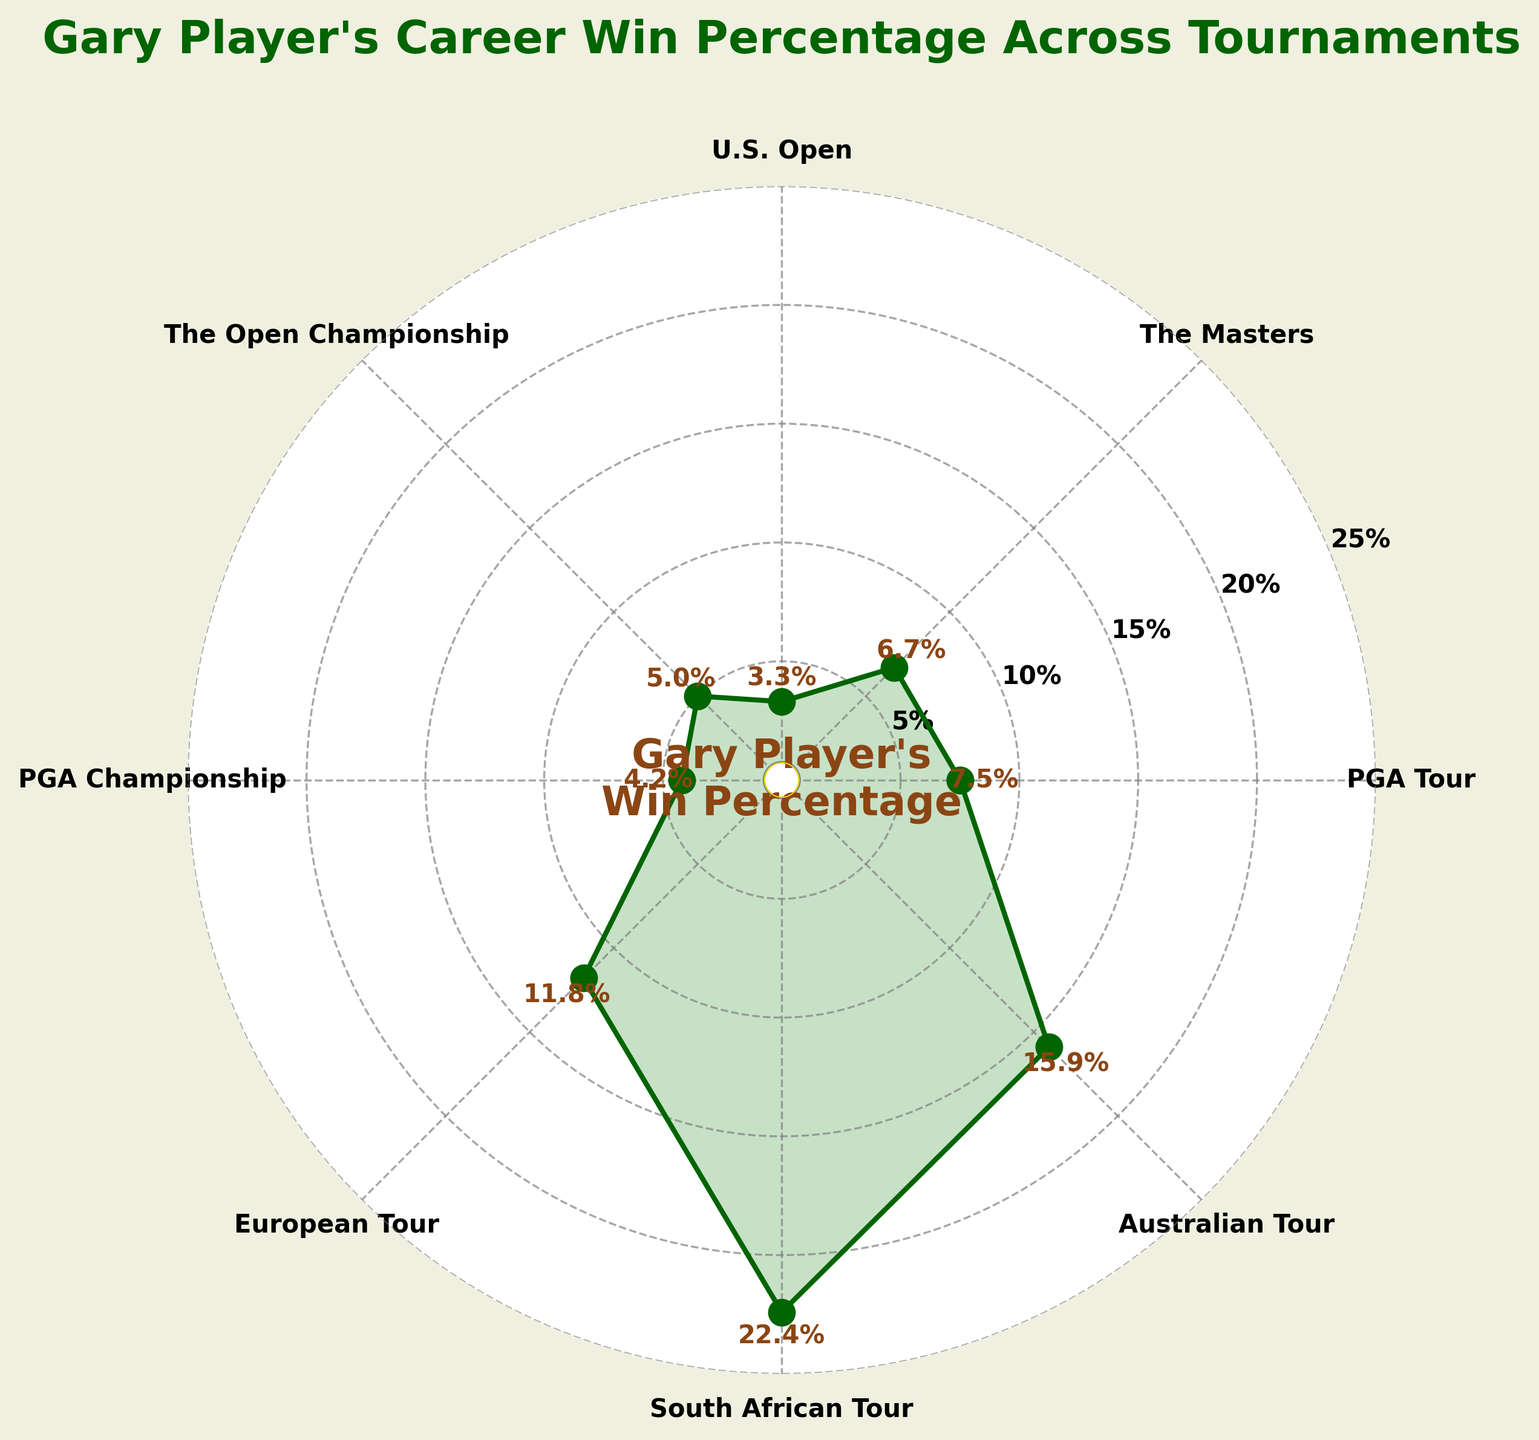what is the win percentage for Gary Player in "The Masters"? The win percentage for "The Masters" is indicated on the plot. It is labeled on the axis and marked with text near the data point. The value is 6.7%.
Answer: 6.7% Which tournament has the highest win percentage? Observing the plot, the highest point on the radial axis corresponds to the South African Tour, which has the win percentage of 22.4%.
Answer: South African Tour How many tournaments have a win percentage higher than 10%? From the plot, count the tournaments which have their percentage values above 10%. These are European Tour, South African Tour, and Australian Tour, making up three tournaments.
Answer: 3 What is the median win percentage across all tournaments? To find the median win percentage, list all the percentages in ascending order: 3.3, 4.2, 5.0, 6.7, 7.5, 11.8, 15.9, 22.4. Since there are 8 values, the median will be the average of the 4th and 5th values in this list: (6.7 + 7.5)/2 = 7.1%.
Answer: 7.1% Which tournament has a win percentage closest to 5%? By comparing the values on the plot, the tournament with a win percentage closest to 5% is The Open Championship, which has a win percentage of precisely 5.0%.
Answer: The Open Championship What is the sum of win percentages for all tournaments? Sum up all the win percentages from the plot: 7.5 + 6.7 + 3.3 + 5.0 + 4.2 + 11.8 + 22.4 + 15.9 = 76.8%.
Answer: 76.8% What is the percentage difference between the win rates for the PGA Tour and the European Tour? Subtract the European Tour percentage (11.8%) from the PGA Tour percentage (7.5%): 11.8 - 7.5 = 4.3%. The difference is 4.3%.
Answer: 4.3% Between the PGA Championship and PGA Tour, which has a higher win percentage and by how much? Compare the win percentages shown on the plot. The PGA Tour has 7.5%, and the PGA Championship has 4.2%. Subtract the smaller from the larger: 7.5 - 4.2 = 3.3%. The PGA Tour has a higher win percentage by 3.3%.
Answer: PGA Tour, 3.3% What pattern can be observed regarding Gary Player's win percentage on the South African Tour compared to the other tournaments? Observing the plot, we can see that the South African Tour win percentage (22.4%) is significantly higher than all other tournaments. This suggests much greater success in this regional tour compared to international ones.
Answer: Significantly higher success What is the average win percentage of all listed tournaments? Calculate the average by summing all win percentages and dividing by the number of tournaments: (7.5 + 6.7 + 3.3 + 5.0 + 4.2 + 11.8 + 22.4 + 15.9) / 8 = 76.8 / 8 = 9.6%.
Answer: 9.6% 